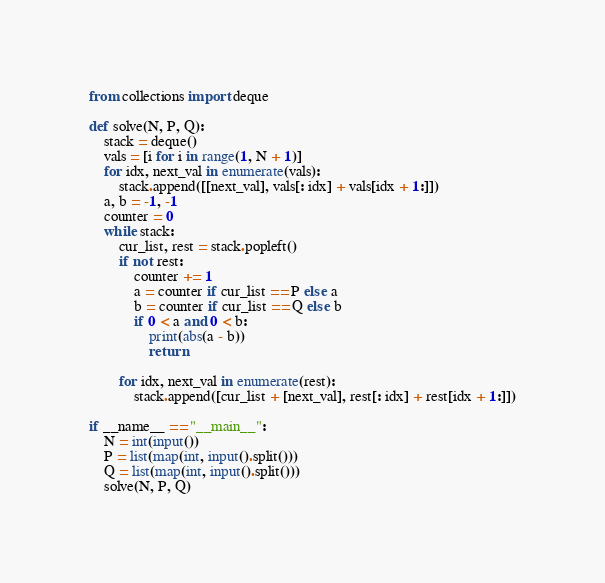<code> <loc_0><loc_0><loc_500><loc_500><_Python_>from collections import deque

def solve(N, P, Q):
    stack = deque()
    vals = [i for i in range(1, N + 1)]
    for idx, next_val in enumerate(vals):
        stack.append([[next_val], vals[: idx] + vals[idx + 1:]])
    a, b = -1, -1
    counter = 0
    while stack:
        cur_list, rest = stack.popleft()
        if not rest:
            counter += 1
            a = counter if cur_list == P else a
            b = counter if cur_list == Q else b
            if 0 < a and 0 < b:
                print(abs(a - b))
                return

        for idx, next_val in enumerate(rest):
            stack.append([cur_list + [next_val], rest[: idx] + rest[idx + 1:]])

if __name__ == "__main__":
    N = int(input())
    P = list(map(int, input().split()))
    Q = list(map(int, input().split()))
    solve(N, P, Q)
</code> 